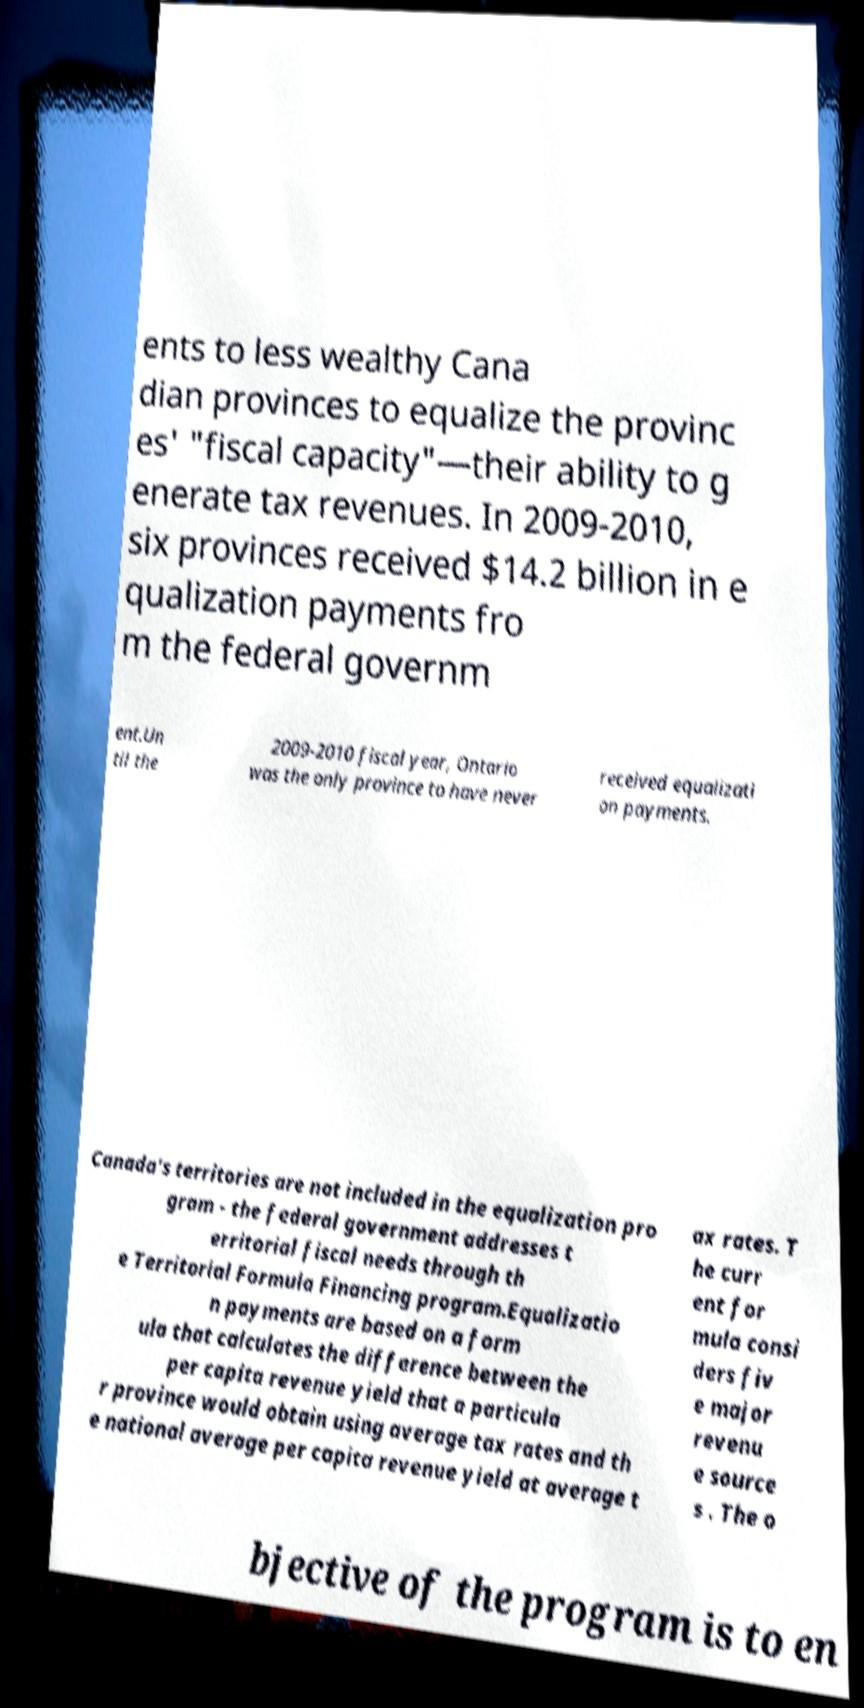There's text embedded in this image that I need extracted. Can you transcribe it verbatim? ents to less wealthy Cana dian provinces to equalize the provinc es' "fiscal capacity"—their ability to g enerate tax revenues. In 2009-2010, six provinces received $14.2 billion in e qualization payments fro m the federal governm ent.Un til the 2009-2010 fiscal year, Ontario was the only province to have never received equalizati on payments. Canada's territories are not included in the equalization pro gram - the federal government addresses t erritorial fiscal needs through th e Territorial Formula Financing program.Equalizatio n payments are based on a form ula that calculates the difference between the per capita revenue yield that a particula r province would obtain using average tax rates and th e national average per capita revenue yield at average t ax rates. T he curr ent for mula consi ders fiv e major revenu e source s . The o bjective of the program is to en 